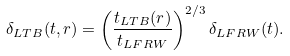Convert formula to latex. <formula><loc_0><loc_0><loc_500><loc_500>\delta _ { L T B } ( t , r ) = \left ( \frac { t _ { L T B } ( r ) } { t _ { L F R W } } \right ) ^ { 2 / 3 } \delta _ { L F R W } ( t ) .</formula> 